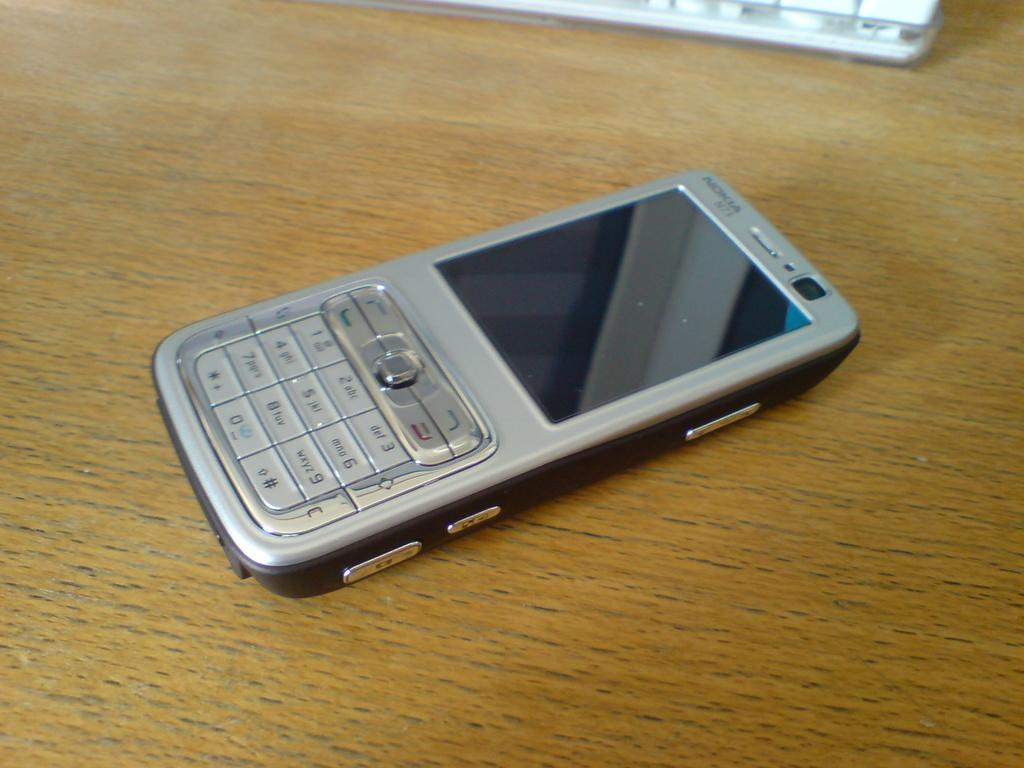<image>
Give a short and clear explanation of the subsequent image. the number 9 is on the gray phone on the table 